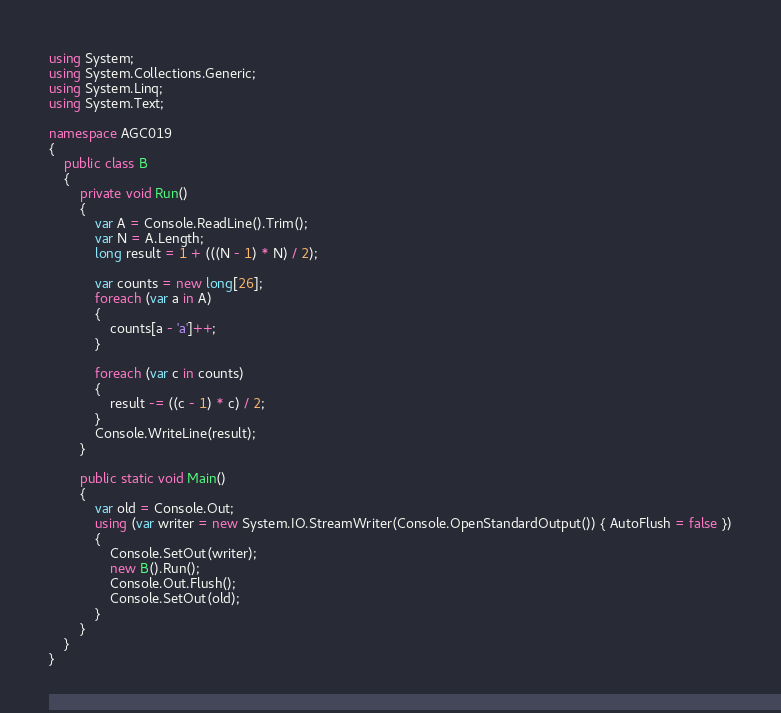Convert code to text. <code><loc_0><loc_0><loc_500><loc_500><_C#_>using System;
using System.Collections.Generic;
using System.Linq;
using System.Text;

namespace AGC019
{
    public class B
    {
        private void Run()
        {
            var A = Console.ReadLine().Trim();
            var N = A.Length;
            long result = 1 + (((N - 1) * N) / 2);

            var counts = new long[26];
            foreach (var a in A)
            {
                counts[a - 'a']++;
            }

            foreach (var c in counts)
            {
                result -= ((c - 1) * c) / 2;
            }
            Console.WriteLine(result);
        }

        public static void Main()
        {
            var old = Console.Out;
            using (var writer = new System.IO.StreamWriter(Console.OpenStandardOutput()) { AutoFlush = false })
            {
                Console.SetOut(writer);
                new B().Run();
                Console.Out.Flush();
                Console.SetOut(old);
            }
        }
    }
}
</code> 